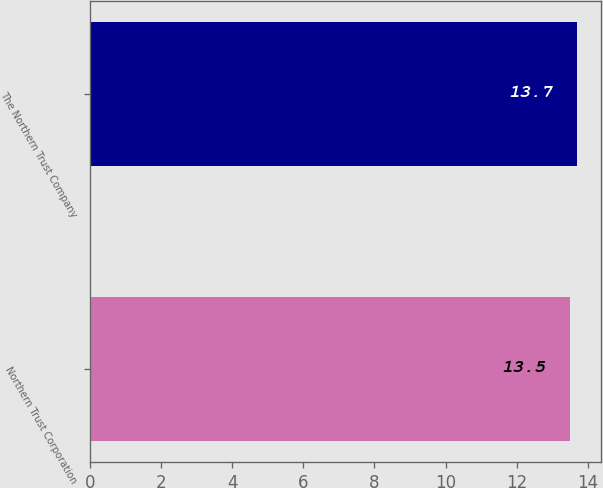Convert chart to OTSL. <chart><loc_0><loc_0><loc_500><loc_500><bar_chart><fcel>Northern Trust Corporation<fcel>The Northern Trust Company<nl><fcel>13.5<fcel>13.7<nl></chart> 